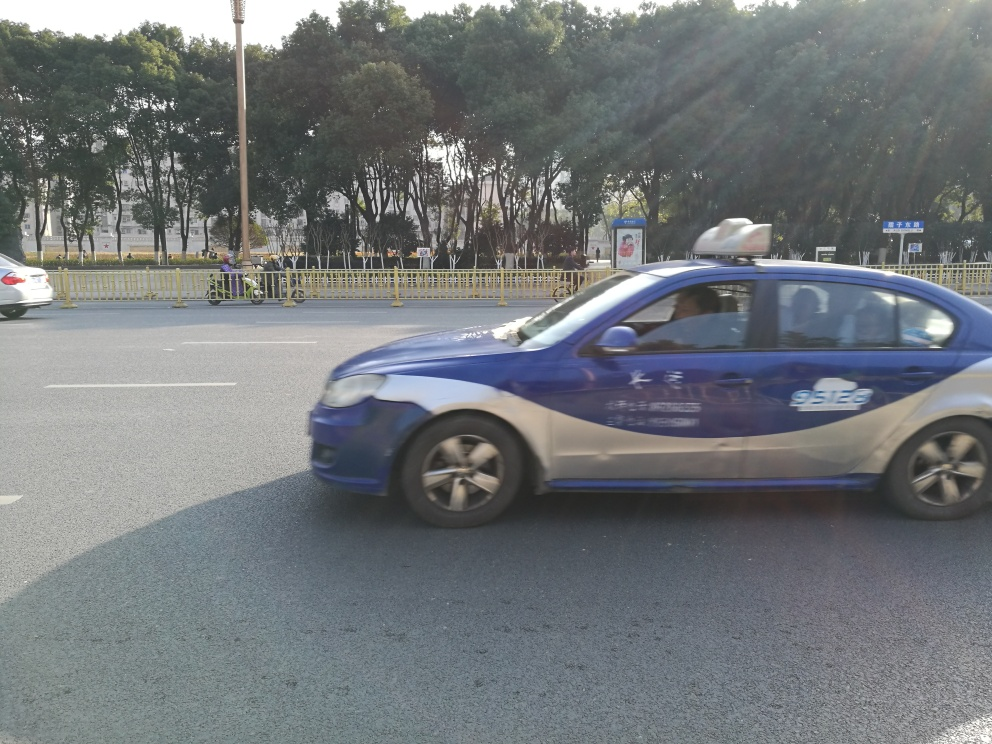Is the image of good quality? The image has adequate lighting and composition, but the main subject, a vehicle, is captured with motion blur which impacts its clarity and sharpness. This suggests that the camera's shutter speed was not fast enough to freeze the movement, resulting in a quality that could be improved for detailed analysis. 